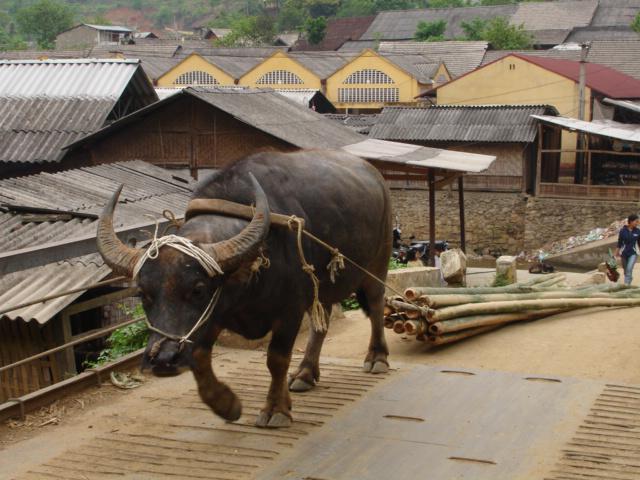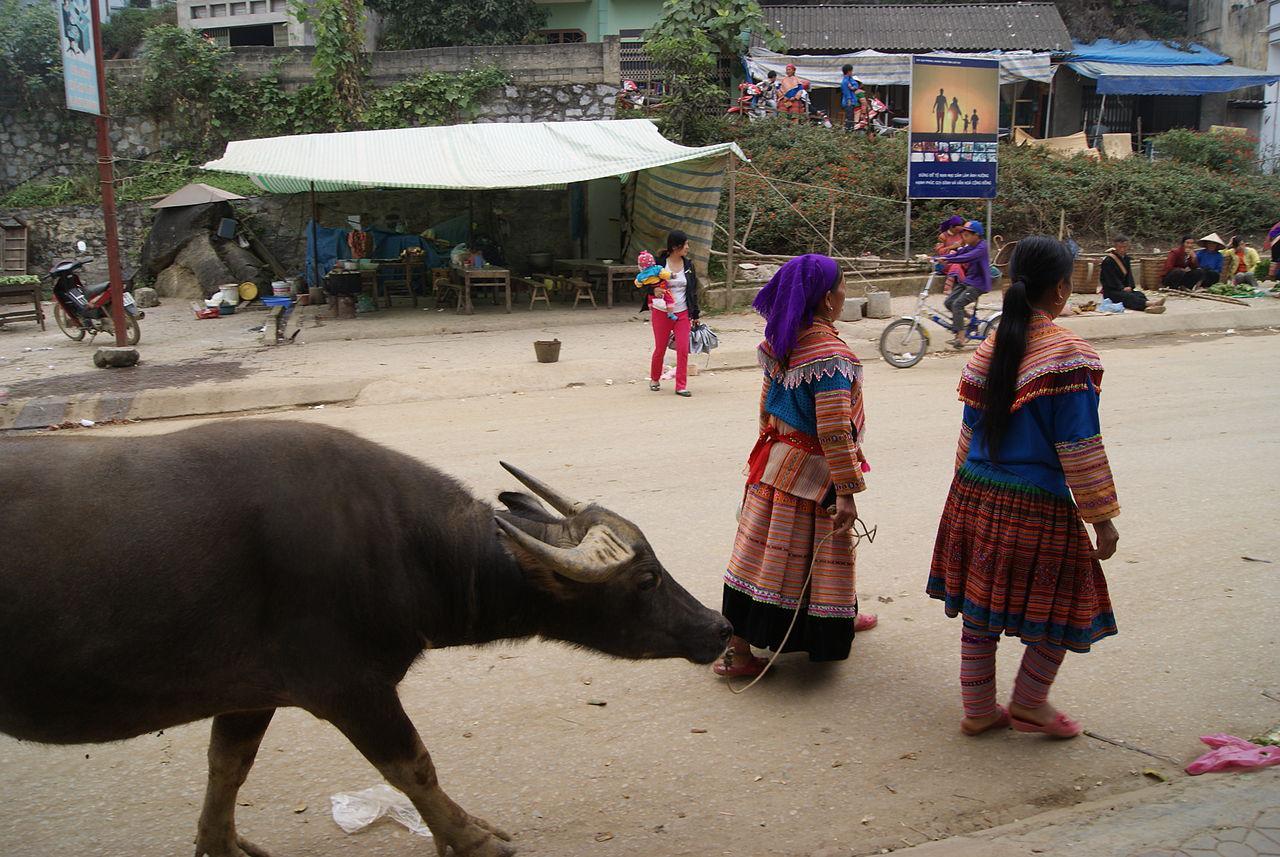The first image is the image on the left, the second image is the image on the right. For the images displayed, is the sentence "An image shows at least one person walking rightward with at least one ox that is not hitched to any wagon." factually correct? Answer yes or no. Yes. The first image is the image on the left, the second image is the image on the right. For the images displayed, is the sentence "A single cow is pulling the load in one of the images." factually correct? Answer yes or no. Yes. 